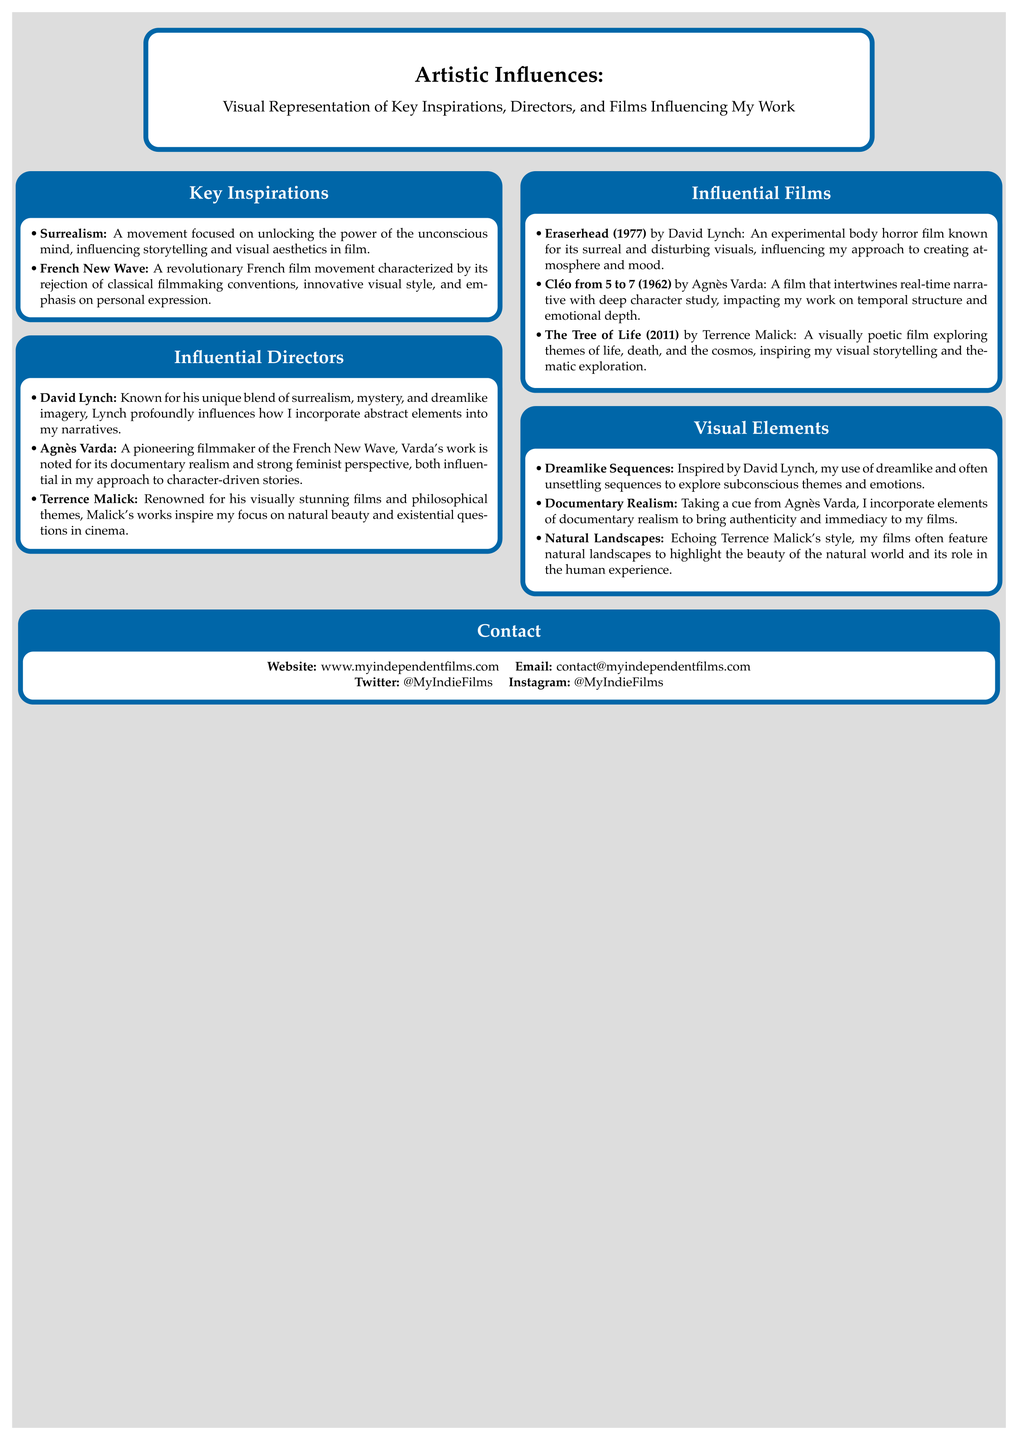What is the main theme of the poster? The main theme is about artistic influences, specifically visual representation of key inspirations in filmmaking.
Answer: Artistic Influences Who are the three influential directors mentioned? The poster lists David Lynch, Agnès Varda, and Terrence Malick as key inspirations for the filmmaker.
Answer: David Lynch, Agnès Varda, Terrence Malick Which film by Agnès Varda is referenced? The film referenced in the document is "Cléo from 5 to 7."
Answer: Cléo from 5 to 7 What artistic movement influences the filmmaker's storytelling? Surrealism is mentioned as a significant influence on the filmmaker's storytelling and visual aesthetics.
Answer: Surrealism Which visual element is inspired by David Lynch? The use of dreamlike sequences is noted as a visual element influenced by David Lynch.
Answer: Dreamlike Sequences How does the filmmaker incorporate elements of documentary realism? The filmmaker takes inspiration from Agnès Varda to bring authenticity to their films.
Answer: Documentary Realism What year was "Eraserhead" released? "Eraserhead," directed by David Lynch, was released in 1977.
Answer: 1977 What is the website listed for contact? The document provides a website for the filmmaker: www.myindependentfilms.com.
Answer: www.myindependentfilms.com 